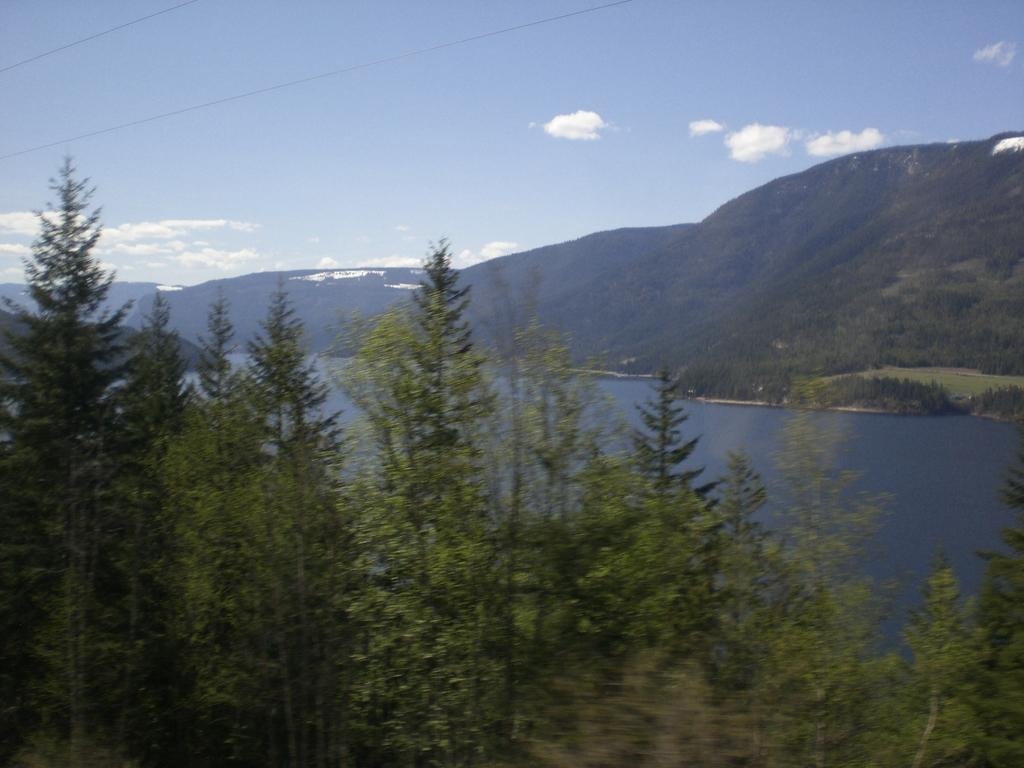How would you summarize this image in a sentence or two? At the bottom there are trees, in the middle there is the water. On the right side there are hills, at the top it is the sky. 